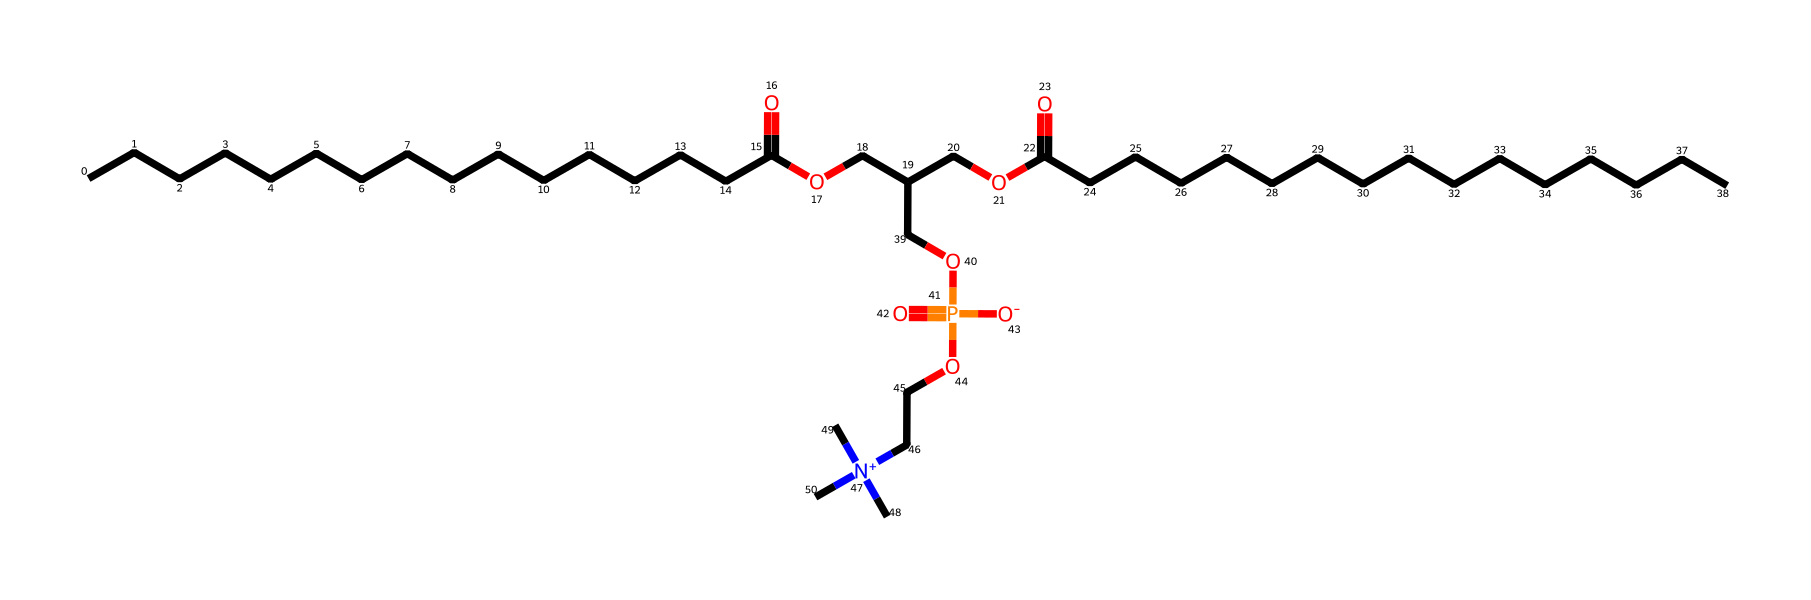What is the molecular formula of phosphatidylcholine? To determine the molecular formula, we identify the elements present in the structure and count their atoms. The molecule contains carbon (C), hydrogen (H), nitrogen (N), oxygen (O), and phosphorus (P). After careful counting of all atoms in the SMILES representation, the formula can be deduced as C32H68N1O8P1.
Answer: C32H68N1O8P1 How many carbon atoms are in this molecule? By analyzing the SMILES representation, we can identify how many carbon atoms are present. Each 'C' in the SMILES indicates a carbon atom, and after counting, we find that there are 32 carbon atoms in total.
Answer: 32 What functional group is present in phosphatidylcholine? Phosphatidylcholine contains an ester functional group, indicated by the presence of a carbonyl group (C=O) next to an alkoxy (O-R) group, specifically in the sn-1 and sn-2 positions configured for phospholipids.
Answer: ester What is the role of the nitrogen in this structure? The nitrogen in the structure, specifically in the quaternary ammonium group, is charged and heavily influences the molecule's solubility and interaction with water and other biological molecules, indicating it plays a significant role in membrane formation.
Answer: membrane interaction What type of lipid is phosphatidylcholine categorized as? Phosphatidylcholine is categorized as a phospholipid because of its phosphate group, which is typical for lipids that form cell membranes, providing structural integrity and fluidity to the bilayer.
Answer: phospholipid How does the size of this lipid compare to other common lipids? Phosphatidylcholine is larger than typical fatty acids, measuring in at 32 carbons, and it is relatively complex compared to simpler lipids due to the presence of a phosphate group and nitrogen, placing it in the classification of complex lipids.
Answer: larger 